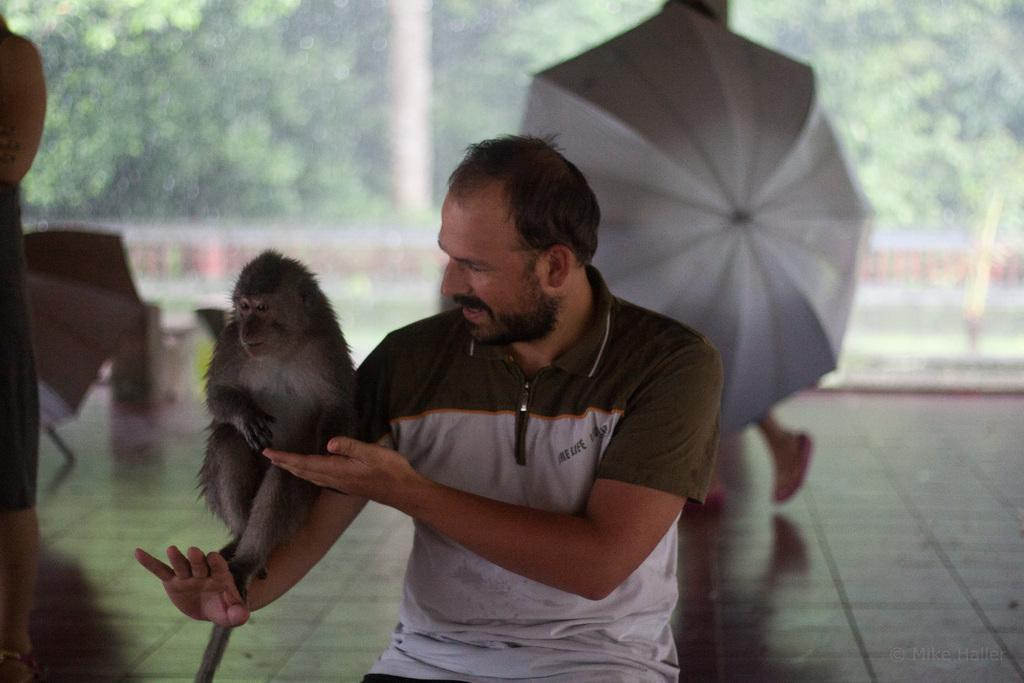Who is present in the image? There is a man in the image. What is the man doing in the image? The man is playing with a monkey. Where is the monkey located in relation to the man? The monkey is on the man's hands. What can be seen in the background of the image? There are people walking in the background of the image, and some of them are holding umbrellas. What type of vegetation is visible in the image? There are trees visible in the image. How many pizzas are being served on the sheet in the image? There is no sheet or pizzas present in the image. Can you tell me how many cacti are visible in the image? There are no cacti visible in the image; only trees are present. 